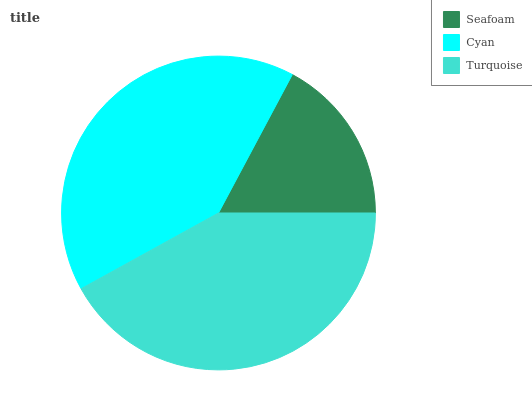Is Seafoam the minimum?
Answer yes or no. Yes. Is Turquoise the maximum?
Answer yes or no. Yes. Is Cyan the minimum?
Answer yes or no. No. Is Cyan the maximum?
Answer yes or no. No. Is Cyan greater than Seafoam?
Answer yes or no. Yes. Is Seafoam less than Cyan?
Answer yes or no. Yes. Is Seafoam greater than Cyan?
Answer yes or no. No. Is Cyan less than Seafoam?
Answer yes or no. No. Is Cyan the high median?
Answer yes or no. Yes. Is Cyan the low median?
Answer yes or no. Yes. Is Turquoise the high median?
Answer yes or no. No. Is Seafoam the low median?
Answer yes or no. No. 